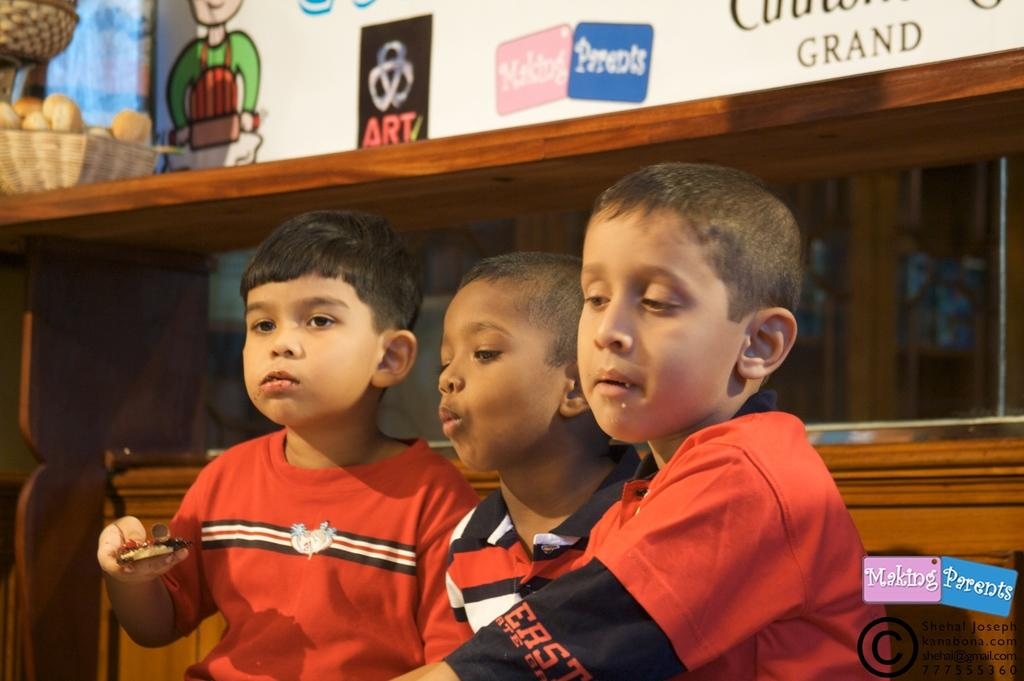How many boys are in the image? There are three boys in the image. What are the boys wearing? The boys are wearing red t-shirts. What can be seen in the background of the image? There is a glass wall in the background of the image. What is at the top of the image? There is a white board at the top of the image. What type of calendar is hanging on the glass wall in the image? There is no calendar visible in the image; only a glass wall is mentioned in the background. 